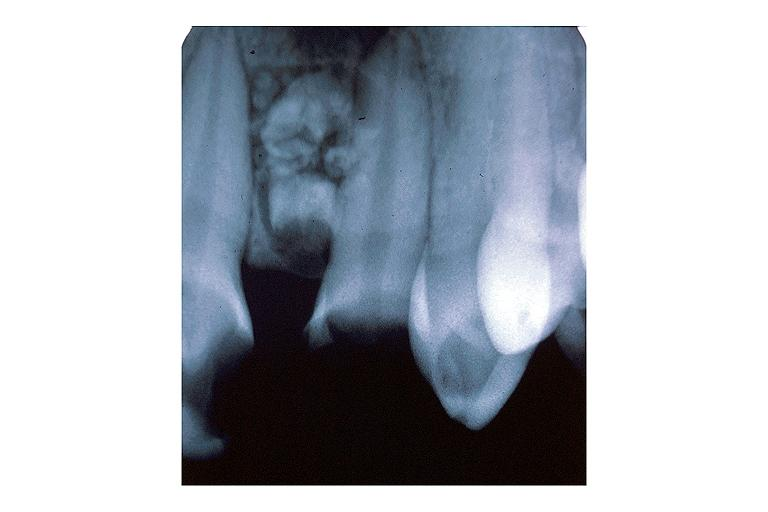what is present?
Answer the question using a single word or phrase. Oral 